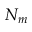<formula> <loc_0><loc_0><loc_500><loc_500>N _ { m }</formula> 